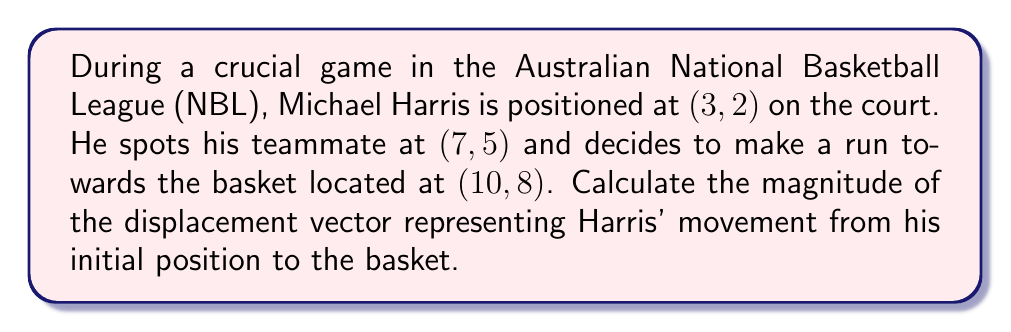Help me with this question. To solve this problem, we'll follow these steps:

1) First, we need to find the displacement vector. This is the vector from Harris' initial position to the basket.

   Initial position: $(3, 2)$
   Basket position: $(10, 8)$

   Displacement vector = Basket position - Initial position
   $$\vec{v} = (10-3, 8-2) = (7, 6)$$

2) Now that we have the displacement vector, we need to calculate its magnitude. The magnitude of a vector $(a, b)$ is given by the formula:

   $$\|\vec{v}\| = \sqrt{a^2 + b^2}$$

3) Substituting our values:

   $$\|\vec{v}\| = \sqrt{7^2 + 6^2}$$

4) Simplify:

   $$\|\vec{v}\| = \sqrt{49 + 36} = \sqrt{85}$$

5) The square root of 85 can't be simplified further, so this is our final answer.

[asy]
unitsize(0.5cm);
draw((-1,-1)--(12,10),gray);
dot((3,2));
dot((7,5));
dot((10,8));
label("Harris (3,2)", (3,2), SW);
label("Teammate (7,5)", (7,5), NE);
label("Basket (10,8)", (10,8), NE);
draw((3,2)--(10,8), arrow=Arrow(TeXHead));
label("Displacement vector", (6.5,5), SE);
[/asy]
Answer: The magnitude of Harris' displacement vector is $\sqrt{85}$ units. 